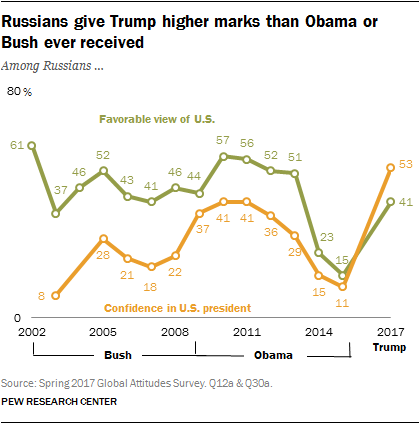Mention a couple of crucial points in this snapshot. The number of colors used in the graph is 2. The green graph contains 2 values that are below 30. 